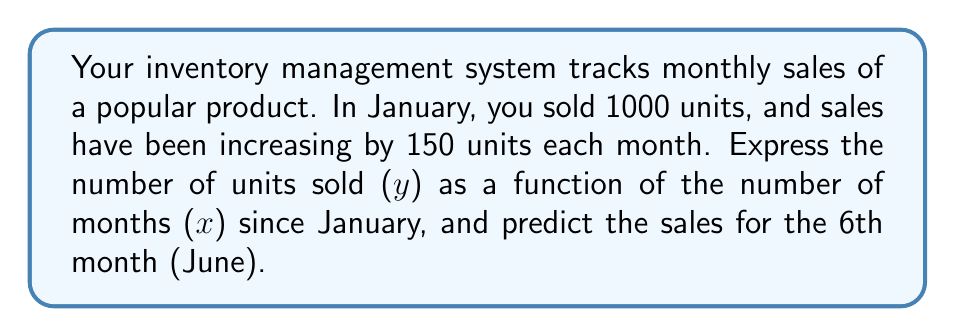What is the answer to this math problem? 1) First, we need to identify the components of our linear equation:
   - Initial value (y-intercept): 1000 units in January (x = 0)
   - Rate of change (slope): Increasing by 150 units each month

2) The general form of a linear equation is:
   $y = mx + b$
   where m is the slope and b is the y-intercept

3) Plugging in our values:
   $y = 150x + 1000$

4) This equation represents our sales trend, where:
   y = number of units sold
   x = number of months since January

5) To predict sales for June (the 6th month), we substitute x = 5 (as January is month 0):
   $y = 150(5) + 1000$
   $y = 750 + 1000$
   $y = 1750$

Therefore, the predicted sales for June (the 6th month) is 1750 units.
Answer: $y = 150x + 1000$; 1750 units 